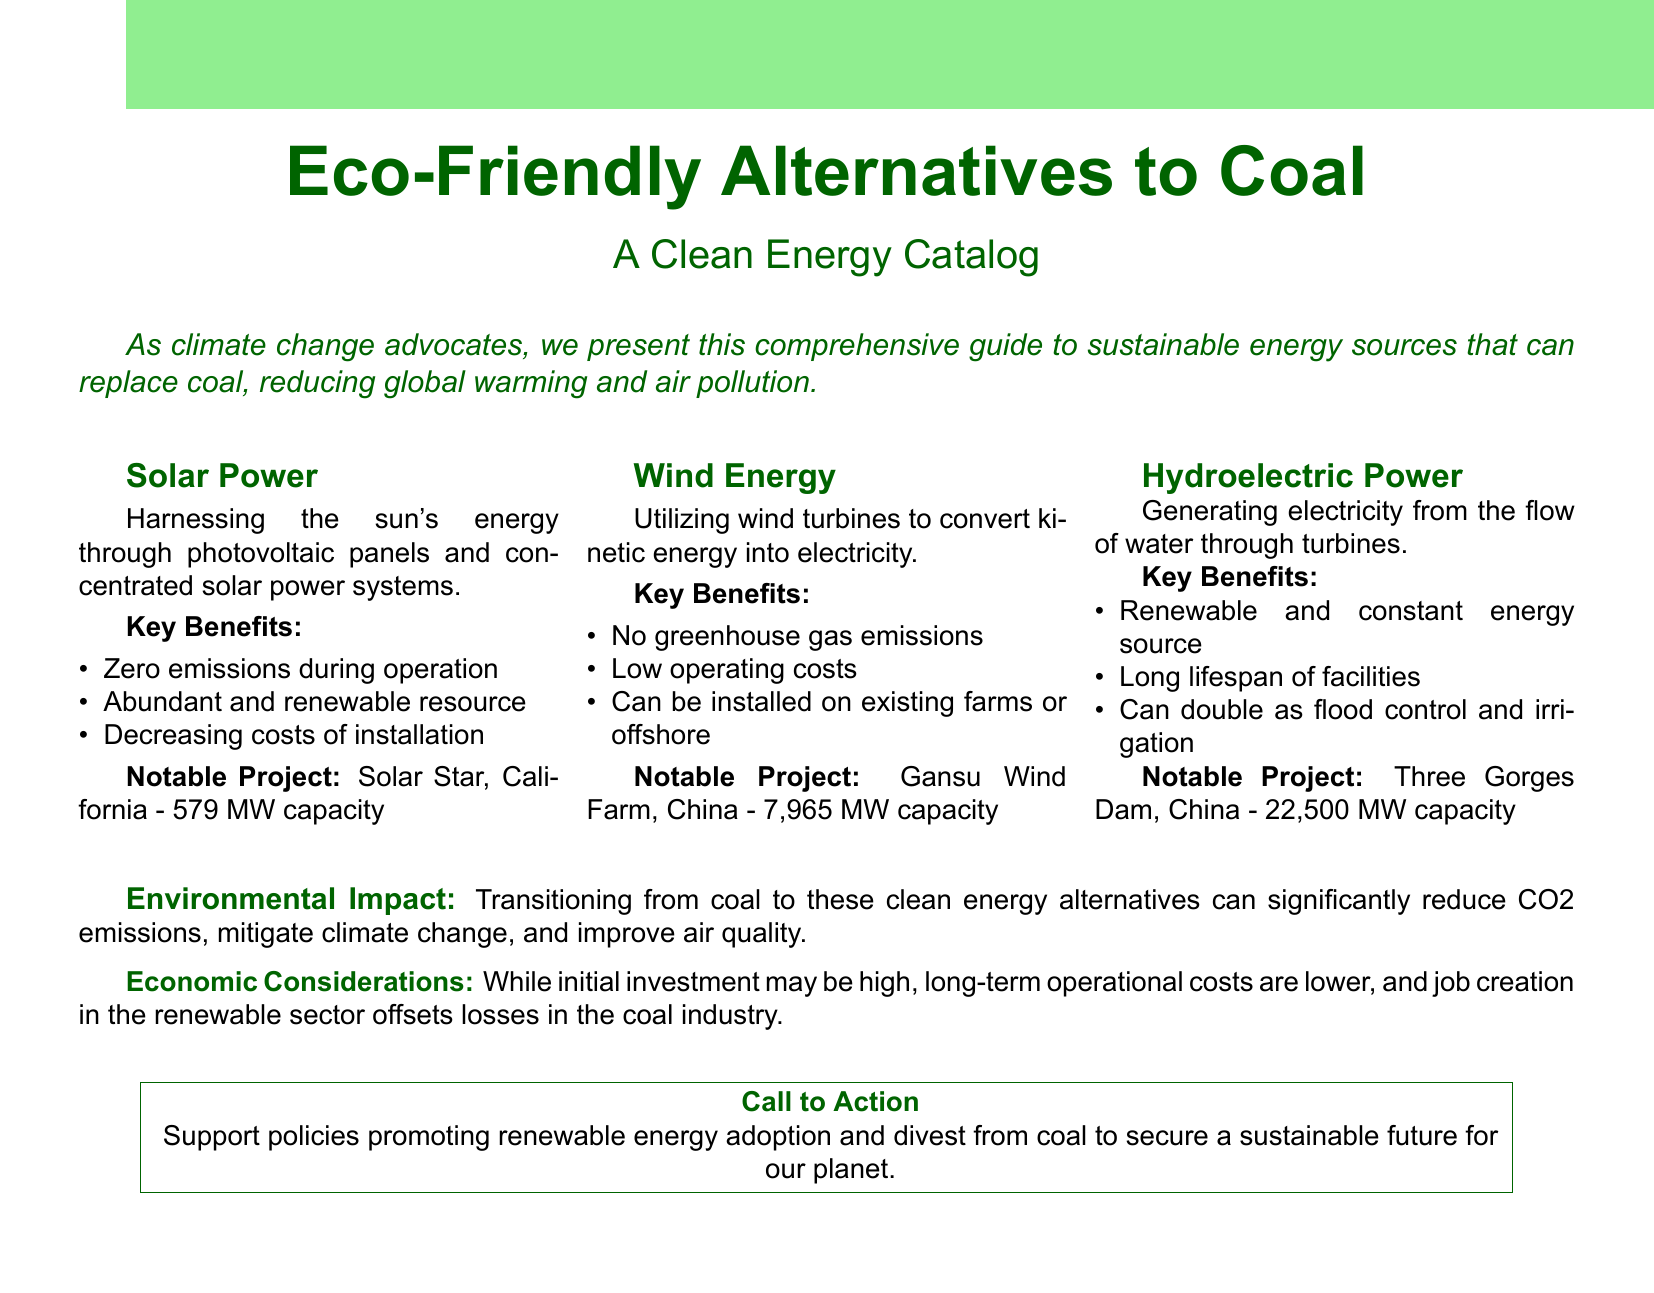What are the three eco-friendly energy alternatives to coal? The document lists solar power, wind energy, and hydroelectric power as alternatives to coal.
Answer: Solar power, wind energy, hydroelectric power What is a key benefit of solar power? The document states that one key benefit of solar power is zero emissions during operation.
Answer: Zero emissions during operation What is the capacity of the Three Gorges Dam? The document mentions that the Three Gorges Dam has a capacity of 22,500 MW.
Answer: 22,500 MW What can hydroelectric power facilities also provide besides electricity? According to the document, hydroelectric power facilities can double as flood control and irrigation.
Answer: Flood control and irrigation What is a notable project for wind energy in China? The Gansu Wind Farm is highlighted in the document as a notable project for wind energy in China.
Answer: Gansu Wind Farm What does transitioning from coal to clean energy alternatives help mitigate? The document indicates that transitioning from coal helps mitigate climate change.
Answer: Climate change What is the main economic consideration regarding renewable energy adoption? The document states that despite high initial investment, long-term operational costs are lower.
Answer: Long-term operational costs are lower What is a call to action presented in the document? The document encourages support for policies promoting renewable energy adoption and divestment from coal.
Answer: Support policies promoting renewable energy adoption 